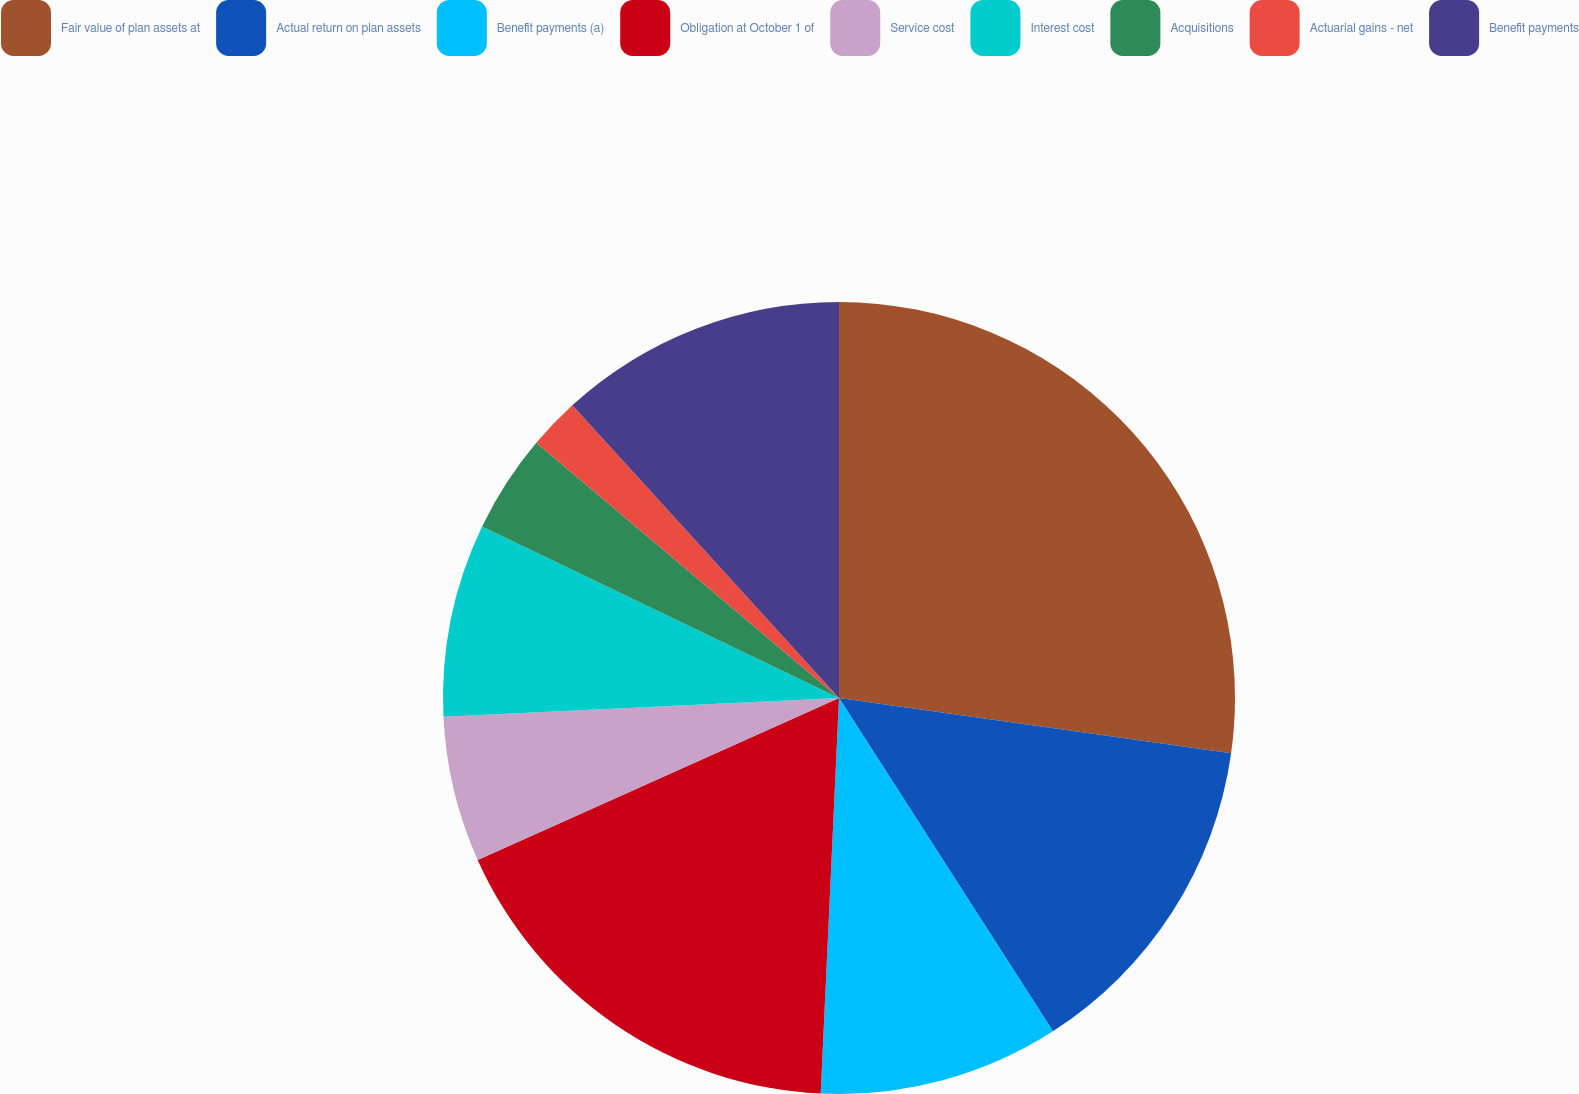Convert chart. <chart><loc_0><loc_0><loc_500><loc_500><pie_chart><fcel>Fair value of plan assets at<fcel>Actual return on plan assets<fcel>Benefit payments (a)<fcel>Obligation at October 1 of<fcel>Service cost<fcel>Interest cost<fcel>Acquisitions<fcel>Actuarial gains - net<fcel>Benefit payments<nl><fcel>27.23%<fcel>13.69%<fcel>9.82%<fcel>17.56%<fcel>5.95%<fcel>7.89%<fcel>4.02%<fcel>2.09%<fcel>11.76%<nl></chart> 